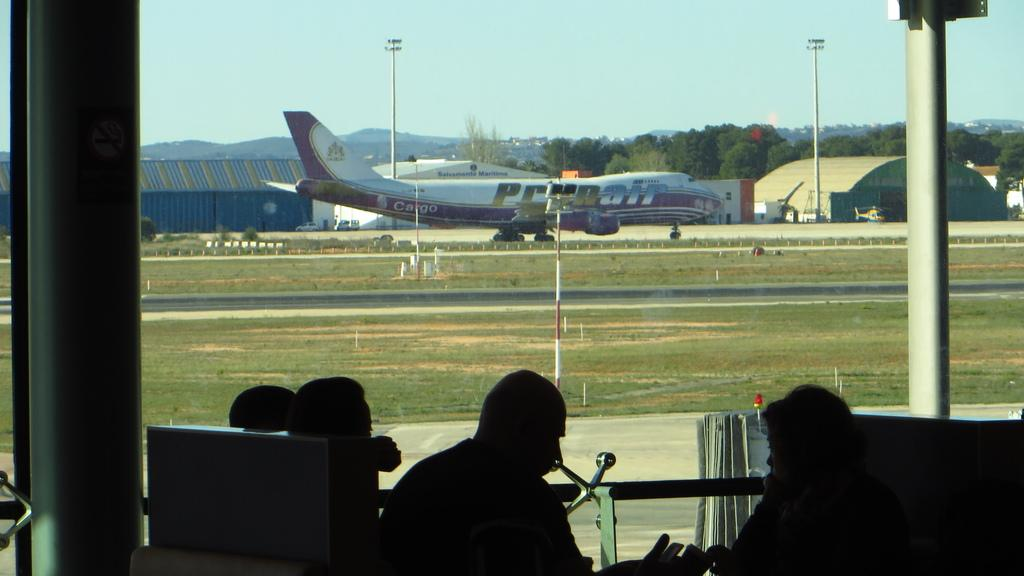<image>
Give a short and clear explanation of the subsequent image. People looking on at a parked airplane with the word CARGO in the back. 